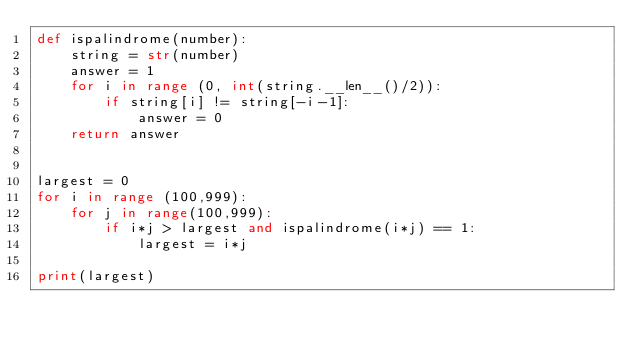<code> <loc_0><loc_0><loc_500><loc_500><_Python_>def ispalindrome(number):
    string = str(number)
    answer = 1
    for i in range (0, int(string.__len__()/2)):
        if string[i] != string[-i-1]:
            answer = 0
    return answer


largest = 0
for i in range (100,999):
    for j in range(100,999):
        if i*j > largest and ispalindrome(i*j) == 1:
            largest = i*j

print(largest)</code> 